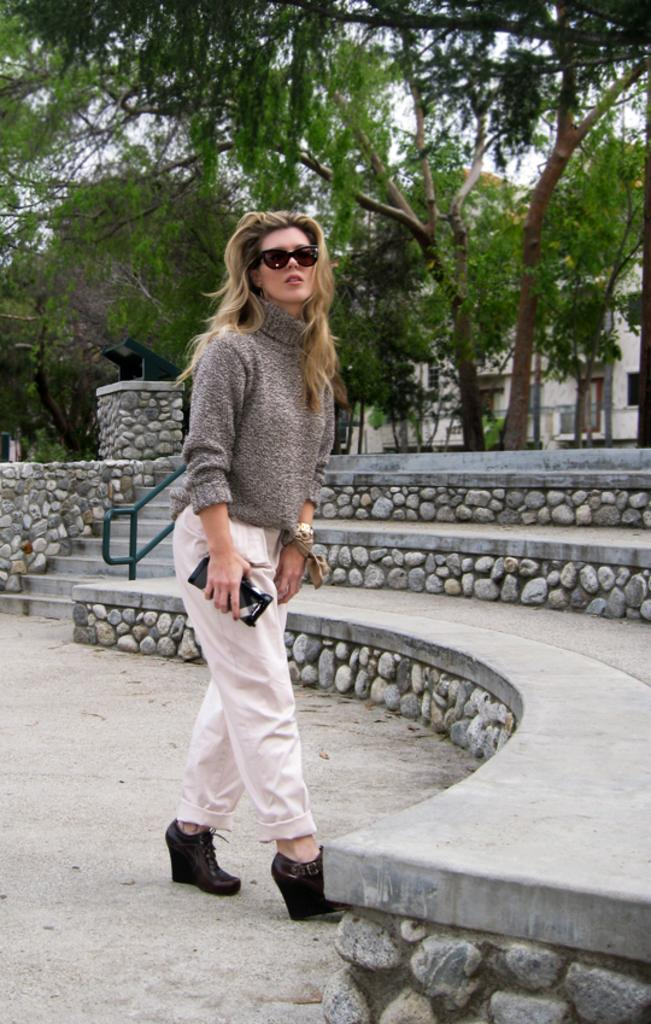What is the lady in the image doing? The lady is standing in the image. What is the lady holding in the image? The lady is holding an object. What type of architectural feature can be seen in the image? There are staircases in the image. What type of structure is present in the image? There is a building in the image. What type of vegetation is visible in the image? There are many trees in the image. What type of comb is the lady using to style her hair in the image? There is no comb visible in the image, nor is the lady's hair being styled. 